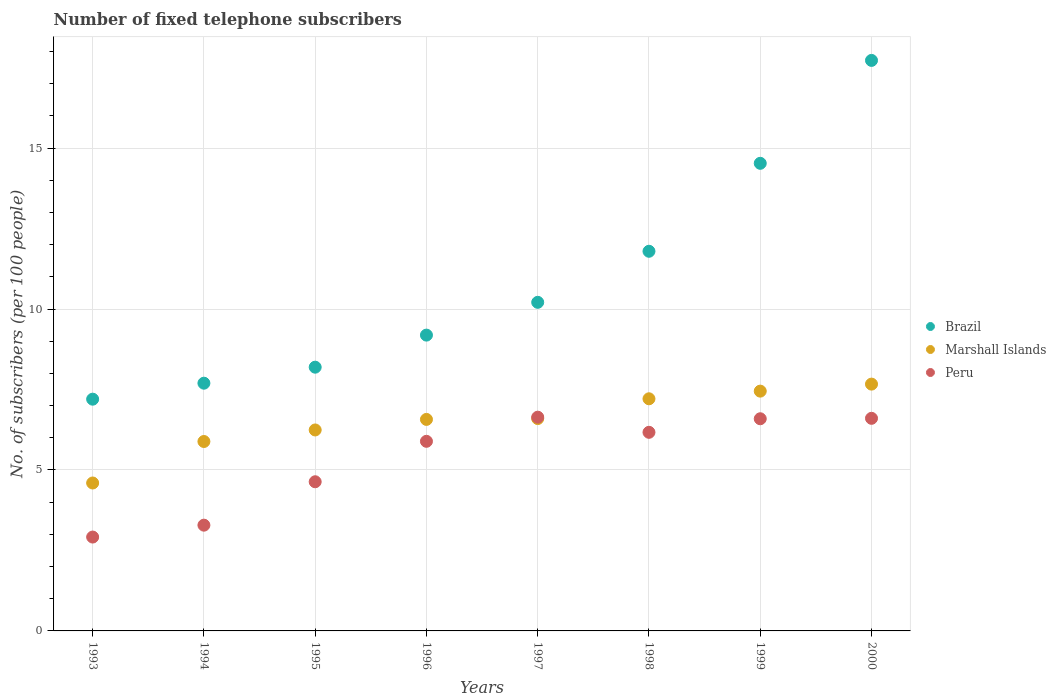How many different coloured dotlines are there?
Your answer should be compact. 3. What is the number of fixed telephone subscribers in Brazil in 2000?
Offer a terse response. 17.72. Across all years, what is the maximum number of fixed telephone subscribers in Peru?
Your response must be concise. 6.64. Across all years, what is the minimum number of fixed telephone subscribers in Marshall Islands?
Offer a terse response. 4.6. In which year was the number of fixed telephone subscribers in Marshall Islands maximum?
Offer a very short reply. 2000. In which year was the number of fixed telephone subscribers in Brazil minimum?
Provide a succinct answer. 1993. What is the total number of fixed telephone subscribers in Peru in the graph?
Offer a very short reply. 42.73. What is the difference between the number of fixed telephone subscribers in Peru in 1993 and that in 1994?
Provide a short and direct response. -0.37. What is the difference between the number of fixed telephone subscribers in Marshall Islands in 1998 and the number of fixed telephone subscribers in Brazil in 1995?
Make the answer very short. -0.98. What is the average number of fixed telephone subscribers in Brazil per year?
Ensure brevity in your answer.  10.82. In the year 1998, what is the difference between the number of fixed telephone subscribers in Brazil and number of fixed telephone subscribers in Marshall Islands?
Your response must be concise. 4.58. In how many years, is the number of fixed telephone subscribers in Marshall Islands greater than 8?
Offer a terse response. 0. What is the ratio of the number of fixed telephone subscribers in Marshall Islands in 1996 to that in 1998?
Your answer should be very brief. 0.91. Is the difference between the number of fixed telephone subscribers in Brazil in 1994 and 2000 greater than the difference between the number of fixed telephone subscribers in Marshall Islands in 1994 and 2000?
Provide a succinct answer. No. What is the difference between the highest and the second highest number of fixed telephone subscribers in Brazil?
Give a very brief answer. 3.2. What is the difference between the highest and the lowest number of fixed telephone subscribers in Peru?
Make the answer very short. 3.72. How many dotlines are there?
Make the answer very short. 3. How many years are there in the graph?
Your answer should be very brief. 8. Are the values on the major ticks of Y-axis written in scientific E-notation?
Your response must be concise. No. Does the graph contain any zero values?
Provide a short and direct response. No. Does the graph contain grids?
Your answer should be compact. Yes. Where does the legend appear in the graph?
Offer a very short reply. Center right. How many legend labels are there?
Your answer should be compact. 3. What is the title of the graph?
Keep it short and to the point. Number of fixed telephone subscribers. What is the label or title of the Y-axis?
Make the answer very short. No. of subscribers (per 100 people). What is the No. of subscribers (per 100 people) in Brazil in 1993?
Make the answer very short. 7.2. What is the No. of subscribers (per 100 people) of Marshall Islands in 1993?
Your answer should be very brief. 4.6. What is the No. of subscribers (per 100 people) of Peru in 1993?
Provide a short and direct response. 2.92. What is the No. of subscribers (per 100 people) in Brazil in 1994?
Make the answer very short. 7.7. What is the No. of subscribers (per 100 people) of Marshall Islands in 1994?
Offer a terse response. 5.88. What is the No. of subscribers (per 100 people) of Peru in 1994?
Provide a short and direct response. 3.29. What is the No. of subscribers (per 100 people) in Brazil in 1995?
Provide a succinct answer. 8.19. What is the No. of subscribers (per 100 people) in Marshall Islands in 1995?
Keep it short and to the point. 6.24. What is the No. of subscribers (per 100 people) in Peru in 1995?
Make the answer very short. 4.63. What is the No. of subscribers (per 100 people) in Brazil in 1996?
Provide a succinct answer. 9.19. What is the No. of subscribers (per 100 people) of Marshall Islands in 1996?
Offer a very short reply. 6.57. What is the No. of subscribers (per 100 people) of Peru in 1996?
Offer a very short reply. 5.89. What is the No. of subscribers (per 100 people) in Brazil in 1997?
Your response must be concise. 10.21. What is the No. of subscribers (per 100 people) of Marshall Islands in 1997?
Make the answer very short. 6.6. What is the No. of subscribers (per 100 people) in Peru in 1997?
Make the answer very short. 6.64. What is the No. of subscribers (per 100 people) in Brazil in 1998?
Provide a short and direct response. 11.79. What is the No. of subscribers (per 100 people) in Marshall Islands in 1998?
Your answer should be very brief. 7.21. What is the No. of subscribers (per 100 people) in Peru in 1998?
Offer a terse response. 6.17. What is the No. of subscribers (per 100 people) of Brazil in 1999?
Provide a succinct answer. 14.53. What is the No. of subscribers (per 100 people) in Marshall Islands in 1999?
Offer a terse response. 7.45. What is the No. of subscribers (per 100 people) of Peru in 1999?
Your answer should be compact. 6.59. What is the No. of subscribers (per 100 people) of Brazil in 2000?
Ensure brevity in your answer.  17.72. What is the No. of subscribers (per 100 people) of Marshall Islands in 2000?
Keep it short and to the point. 7.67. What is the No. of subscribers (per 100 people) of Peru in 2000?
Provide a succinct answer. 6.6. Across all years, what is the maximum No. of subscribers (per 100 people) of Brazil?
Provide a succinct answer. 17.72. Across all years, what is the maximum No. of subscribers (per 100 people) in Marshall Islands?
Provide a succinct answer. 7.67. Across all years, what is the maximum No. of subscribers (per 100 people) of Peru?
Offer a very short reply. 6.64. Across all years, what is the minimum No. of subscribers (per 100 people) in Brazil?
Make the answer very short. 7.2. Across all years, what is the minimum No. of subscribers (per 100 people) of Marshall Islands?
Ensure brevity in your answer.  4.6. Across all years, what is the minimum No. of subscribers (per 100 people) in Peru?
Offer a very short reply. 2.92. What is the total No. of subscribers (per 100 people) of Brazil in the graph?
Keep it short and to the point. 86.52. What is the total No. of subscribers (per 100 people) in Marshall Islands in the graph?
Provide a short and direct response. 52.21. What is the total No. of subscribers (per 100 people) in Peru in the graph?
Give a very brief answer. 42.73. What is the difference between the No. of subscribers (per 100 people) of Brazil in 1993 and that in 1994?
Provide a short and direct response. -0.5. What is the difference between the No. of subscribers (per 100 people) of Marshall Islands in 1993 and that in 1994?
Offer a terse response. -1.29. What is the difference between the No. of subscribers (per 100 people) in Peru in 1993 and that in 1994?
Your response must be concise. -0.37. What is the difference between the No. of subscribers (per 100 people) of Brazil in 1993 and that in 1995?
Make the answer very short. -0.99. What is the difference between the No. of subscribers (per 100 people) of Marshall Islands in 1993 and that in 1995?
Offer a very short reply. -1.65. What is the difference between the No. of subscribers (per 100 people) of Peru in 1993 and that in 1995?
Offer a very short reply. -1.72. What is the difference between the No. of subscribers (per 100 people) in Brazil in 1993 and that in 1996?
Keep it short and to the point. -1.99. What is the difference between the No. of subscribers (per 100 people) of Marshall Islands in 1993 and that in 1996?
Offer a terse response. -1.98. What is the difference between the No. of subscribers (per 100 people) in Peru in 1993 and that in 1996?
Your answer should be compact. -2.97. What is the difference between the No. of subscribers (per 100 people) of Brazil in 1993 and that in 1997?
Your response must be concise. -3.01. What is the difference between the No. of subscribers (per 100 people) in Marshall Islands in 1993 and that in 1997?
Keep it short and to the point. -2. What is the difference between the No. of subscribers (per 100 people) in Peru in 1993 and that in 1997?
Give a very brief answer. -3.72. What is the difference between the No. of subscribers (per 100 people) in Brazil in 1993 and that in 1998?
Provide a succinct answer. -4.59. What is the difference between the No. of subscribers (per 100 people) in Marshall Islands in 1993 and that in 1998?
Ensure brevity in your answer.  -2.62. What is the difference between the No. of subscribers (per 100 people) of Peru in 1993 and that in 1998?
Keep it short and to the point. -3.25. What is the difference between the No. of subscribers (per 100 people) of Brazil in 1993 and that in 1999?
Offer a terse response. -7.33. What is the difference between the No. of subscribers (per 100 people) in Marshall Islands in 1993 and that in 1999?
Make the answer very short. -2.85. What is the difference between the No. of subscribers (per 100 people) of Peru in 1993 and that in 1999?
Your response must be concise. -3.67. What is the difference between the No. of subscribers (per 100 people) in Brazil in 1993 and that in 2000?
Keep it short and to the point. -10.52. What is the difference between the No. of subscribers (per 100 people) in Marshall Islands in 1993 and that in 2000?
Make the answer very short. -3.07. What is the difference between the No. of subscribers (per 100 people) of Peru in 1993 and that in 2000?
Offer a terse response. -3.69. What is the difference between the No. of subscribers (per 100 people) in Brazil in 1994 and that in 1995?
Your answer should be compact. -0.5. What is the difference between the No. of subscribers (per 100 people) in Marshall Islands in 1994 and that in 1995?
Your answer should be compact. -0.36. What is the difference between the No. of subscribers (per 100 people) in Peru in 1994 and that in 1995?
Your answer should be compact. -1.35. What is the difference between the No. of subscribers (per 100 people) of Brazil in 1994 and that in 1996?
Give a very brief answer. -1.49. What is the difference between the No. of subscribers (per 100 people) of Marshall Islands in 1994 and that in 1996?
Your response must be concise. -0.69. What is the difference between the No. of subscribers (per 100 people) in Peru in 1994 and that in 1996?
Offer a very short reply. -2.6. What is the difference between the No. of subscribers (per 100 people) of Brazil in 1994 and that in 1997?
Your answer should be compact. -2.51. What is the difference between the No. of subscribers (per 100 people) of Marshall Islands in 1994 and that in 1997?
Your answer should be very brief. -0.71. What is the difference between the No. of subscribers (per 100 people) in Peru in 1994 and that in 1997?
Keep it short and to the point. -3.35. What is the difference between the No. of subscribers (per 100 people) in Brazil in 1994 and that in 1998?
Give a very brief answer. -4.1. What is the difference between the No. of subscribers (per 100 people) of Marshall Islands in 1994 and that in 1998?
Your answer should be compact. -1.33. What is the difference between the No. of subscribers (per 100 people) of Peru in 1994 and that in 1998?
Your answer should be very brief. -2.88. What is the difference between the No. of subscribers (per 100 people) in Brazil in 1994 and that in 1999?
Keep it short and to the point. -6.83. What is the difference between the No. of subscribers (per 100 people) in Marshall Islands in 1994 and that in 1999?
Your answer should be compact. -1.56. What is the difference between the No. of subscribers (per 100 people) of Peru in 1994 and that in 1999?
Keep it short and to the point. -3.31. What is the difference between the No. of subscribers (per 100 people) in Brazil in 1994 and that in 2000?
Make the answer very short. -10.03. What is the difference between the No. of subscribers (per 100 people) in Marshall Islands in 1994 and that in 2000?
Your answer should be compact. -1.78. What is the difference between the No. of subscribers (per 100 people) in Peru in 1994 and that in 2000?
Give a very brief answer. -3.32. What is the difference between the No. of subscribers (per 100 people) of Brazil in 1995 and that in 1996?
Offer a terse response. -1. What is the difference between the No. of subscribers (per 100 people) in Marshall Islands in 1995 and that in 1996?
Your response must be concise. -0.33. What is the difference between the No. of subscribers (per 100 people) in Peru in 1995 and that in 1996?
Your answer should be compact. -1.26. What is the difference between the No. of subscribers (per 100 people) of Brazil in 1995 and that in 1997?
Give a very brief answer. -2.01. What is the difference between the No. of subscribers (per 100 people) in Marshall Islands in 1995 and that in 1997?
Your response must be concise. -0.35. What is the difference between the No. of subscribers (per 100 people) of Peru in 1995 and that in 1997?
Provide a short and direct response. -2.01. What is the difference between the No. of subscribers (per 100 people) in Brazil in 1995 and that in 1998?
Your answer should be compact. -3.6. What is the difference between the No. of subscribers (per 100 people) in Marshall Islands in 1995 and that in 1998?
Your answer should be very brief. -0.97. What is the difference between the No. of subscribers (per 100 people) of Peru in 1995 and that in 1998?
Keep it short and to the point. -1.54. What is the difference between the No. of subscribers (per 100 people) of Brazil in 1995 and that in 1999?
Keep it short and to the point. -6.33. What is the difference between the No. of subscribers (per 100 people) in Marshall Islands in 1995 and that in 1999?
Offer a very short reply. -1.21. What is the difference between the No. of subscribers (per 100 people) in Peru in 1995 and that in 1999?
Provide a succinct answer. -1.96. What is the difference between the No. of subscribers (per 100 people) of Brazil in 1995 and that in 2000?
Your answer should be very brief. -9.53. What is the difference between the No. of subscribers (per 100 people) in Marshall Islands in 1995 and that in 2000?
Keep it short and to the point. -1.42. What is the difference between the No. of subscribers (per 100 people) of Peru in 1995 and that in 2000?
Ensure brevity in your answer.  -1.97. What is the difference between the No. of subscribers (per 100 people) in Brazil in 1996 and that in 1997?
Your answer should be very brief. -1.02. What is the difference between the No. of subscribers (per 100 people) in Marshall Islands in 1996 and that in 1997?
Make the answer very short. -0.03. What is the difference between the No. of subscribers (per 100 people) in Peru in 1996 and that in 1997?
Your response must be concise. -0.75. What is the difference between the No. of subscribers (per 100 people) of Brazil in 1996 and that in 1998?
Keep it short and to the point. -2.6. What is the difference between the No. of subscribers (per 100 people) in Marshall Islands in 1996 and that in 1998?
Your response must be concise. -0.64. What is the difference between the No. of subscribers (per 100 people) of Peru in 1996 and that in 1998?
Provide a short and direct response. -0.28. What is the difference between the No. of subscribers (per 100 people) of Brazil in 1996 and that in 1999?
Provide a short and direct response. -5.34. What is the difference between the No. of subscribers (per 100 people) of Marshall Islands in 1996 and that in 1999?
Make the answer very short. -0.88. What is the difference between the No. of subscribers (per 100 people) of Peru in 1996 and that in 1999?
Offer a very short reply. -0.7. What is the difference between the No. of subscribers (per 100 people) of Brazil in 1996 and that in 2000?
Your answer should be compact. -8.53. What is the difference between the No. of subscribers (per 100 people) of Marshall Islands in 1996 and that in 2000?
Your answer should be compact. -1.1. What is the difference between the No. of subscribers (per 100 people) in Peru in 1996 and that in 2000?
Make the answer very short. -0.71. What is the difference between the No. of subscribers (per 100 people) in Brazil in 1997 and that in 1998?
Your response must be concise. -1.59. What is the difference between the No. of subscribers (per 100 people) of Marshall Islands in 1997 and that in 1998?
Offer a very short reply. -0.61. What is the difference between the No. of subscribers (per 100 people) in Peru in 1997 and that in 1998?
Your answer should be compact. 0.47. What is the difference between the No. of subscribers (per 100 people) of Brazil in 1997 and that in 1999?
Offer a terse response. -4.32. What is the difference between the No. of subscribers (per 100 people) in Marshall Islands in 1997 and that in 1999?
Ensure brevity in your answer.  -0.85. What is the difference between the No. of subscribers (per 100 people) of Peru in 1997 and that in 1999?
Your answer should be very brief. 0.05. What is the difference between the No. of subscribers (per 100 people) of Brazil in 1997 and that in 2000?
Your response must be concise. -7.51. What is the difference between the No. of subscribers (per 100 people) in Marshall Islands in 1997 and that in 2000?
Provide a succinct answer. -1.07. What is the difference between the No. of subscribers (per 100 people) of Peru in 1997 and that in 2000?
Keep it short and to the point. 0.04. What is the difference between the No. of subscribers (per 100 people) in Brazil in 1998 and that in 1999?
Give a very brief answer. -2.73. What is the difference between the No. of subscribers (per 100 people) of Marshall Islands in 1998 and that in 1999?
Your answer should be compact. -0.24. What is the difference between the No. of subscribers (per 100 people) of Peru in 1998 and that in 1999?
Offer a terse response. -0.42. What is the difference between the No. of subscribers (per 100 people) of Brazil in 1998 and that in 2000?
Offer a terse response. -5.93. What is the difference between the No. of subscribers (per 100 people) in Marshall Islands in 1998 and that in 2000?
Your answer should be compact. -0.46. What is the difference between the No. of subscribers (per 100 people) in Peru in 1998 and that in 2000?
Offer a very short reply. -0.43. What is the difference between the No. of subscribers (per 100 people) of Brazil in 1999 and that in 2000?
Provide a succinct answer. -3.2. What is the difference between the No. of subscribers (per 100 people) of Marshall Islands in 1999 and that in 2000?
Your answer should be compact. -0.22. What is the difference between the No. of subscribers (per 100 people) in Peru in 1999 and that in 2000?
Your answer should be compact. -0.01. What is the difference between the No. of subscribers (per 100 people) in Brazil in 1993 and the No. of subscribers (per 100 people) in Marshall Islands in 1994?
Make the answer very short. 1.31. What is the difference between the No. of subscribers (per 100 people) of Brazil in 1993 and the No. of subscribers (per 100 people) of Peru in 1994?
Ensure brevity in your answer.  3.91. What is the difference between the No. of subscribers (per 100 people) of Marshall Islands in 1993 and the No. of subscribers (per 100 people) of Peru in 1994?
Provide a short and direct response. 1.31. What is the difference between the No. of subscribers (per 100 people) in Brazil in 1993 and the No. of subscribers (per 100 people) in Marshall Islands in 1995?
Provide a short and direct response. 0.96. What is the difference between the No. of subscribers (per 100 people) of Brazil in 1993 and the No. of subscribers (per 100 people) of Peru in 1995?
Provide a succinct answer. 2.57. What is the difference between the No. of subscribers (per 100 people) of Marshall Islands in 1993 and the No. of subscribers (per 100 people) of Peru in 1995?
Ensure brevity in your answer.  -0.04. What is the difference between the No. of subscribers (per 100 people) in Brazil in 1993 and the No. of subscribers (per 100 people) in Marshall Islands in 1996?
Keep it short and to the point. 0.63. What is the difference between the No. of subscribers (per 100 people) of Brazil in 1993 and the No. of subscribers (per 100 people) of Peru in 1996?
Your answer should be compact. 1.31. What is the difference between the No. of subscribers (per 100 people) of Marshall Islands in 1993 and the No. of subscribers (per 100 people) of Peru in 1996?
Give a very brief answer. -1.29. What is the difference between the No. of subscribers (per 100 people) in Brazil in 1993 and the No. of subscribers (per 100 people) in Marshall Islands in 1997?
Your response must be concise. 0.6. What is the difference between the No. of subscribers (per 100 people) in Brazil in 1993 and the No. of subscribers (per 100 people) in Peru in 1997?
Provide a succinct answer. 0.56. What is the difference between the No. of subscribers (per 100 people) of Marshall Islands in 1993 and the No. of subscribers (per 100 people) of Peru in 1997?
Your response must be concise. -2.04. What is the difference between the No. of subscribers (per 100 people) in Brazil in 1993 and the No. of subscribers (per 100 people) in Marshall Islands in 1998?
Your response must be concise. -0.01. What is the difference between the No. of subscribers (per 100 people) in Brazil in 1993 and the No. of subscribers (per 100 people) in Peru in 1998?
Your response must be concise. 1.03. What is the difference between the No. of subscribers (per 100 people) in Marshall Islands in 1993 and the No. of subscribers (per 100 people) in Peru in 1998?
Offer a very short reply. -1.57. What is the difference between the No. of subscribers (per 100 people) of Brazil in 1993 and the No. of subscribers (per 100 people) of Marshall Islands in 1999?
Your answer should be very brief. -0.25. What is the difference between the No. of subscribers (per 100 people) of Brazil in 1993 and the No. of subscribers (per 100 people) of Peru in 1999?
Make the answer very short. 0.61. What is the difference between the No. of subscribers (per 100 people) of Marshall Islands in 1993 and the No. of subscribers (per 100 people) of Peru in 1999?
Make the answer very short. -2. What is the difference between the No. of subscribers (per 100 people) in Brazil in 1993 and the No. of subscribers (per 100 people) in Marshall Islands in 2000?
Provide a short and direct response. -0.47. What is the difference between the No. of subscribers (per 100 people) of Brazil in 1993 and the No. of subscribers (per 100 people) of Peru in 2000?
Provide a short and direct response. 0.59. What is the difference between the No. of subscribers (per 100 people) of Marshall Islands in 1993 and the No. of subscribers (per 100 people) of Peru in 2000?
Offer a terse response. -2.01. What is the difference between the No. of subscribers (per 100 people) of Brazil in 1994 and the No. of subscribers (per 100 people) of Marshall Islands in 1995?
Keep it short and to the point. 1.45. What is the difference between the No. of subscribers (per 100 people) of Brazil in 1994 and the No. of subscribers (per 100 people) of Peru in 1995?
Provide a succinct answer. 3.06. What is the difference between the No. of subscribers (per 100 people) in Marshall Islands in 1994 and the No. of subscribers (per 100 people) in Peru in 1995?
Provide a succinct answer. 1.25. What is the difference between the No. of subscribers (per 100 people) in Brazil in 1994 and the No. of subscribers (per 100 people) in Marshall Islands in 1996?
Your answer should be compact. 1.12. What is the difference between the No. of subscribers (per 100 people) in Brazil in 1994 and the No. of subscribers (per 100 people) in Peru in 1996?
Your answer should be compact. 1.81. What is the difference between the No. of subscribers (per 100 people) in Marshall Islands in 1994 and the No. of subscribers (per 100 people) in Peru in 1996?
Provide a short and direct response. -0.01. What is the difference between the No. of subscribers (per 100 people) in Brazil in 1994 and the No. of subscribers (per 100 people) in Marshall Islands in 1997?
Provide a short and direct response. 1.1. What is the difference between the No. of subscribers (per 100 people) in Brazil in 1994 and the No. of subscribers (per 100 people) in Peru in 1997?
Your response must be concise. 1.06. What is the difference between the No. of subscribers (per 100 people) in Marshall Islands in 1994 and the No. of subscribers (per 100 people) in Peru in 1997?
Give a very brief answer. -0.76. What is the difference between the No. of subscribers (per 100 people) of Brazil in 1994 and the No. of subscribers (per 100 people) of Marshall Islands in 1998?
Ensure brevity in your answer.  0.48. What is the difference between the No. of subscribers (per 100 people) in Brazil in 1994 and the No. of subscribers (per 100 people) in Peru in 1998?
Offer a very short reply. 1.53. What is the difference between the No. of subscribers (per 100 people) of Marshall Islands in 1994 and the No. of subscribers (per 100 people) of Peru in 1998?
Your answer should be very brief. -0.29. What is the difference between the No. of subscribers (per 100 people) of Brazil in 1994 and the No. of subscribers (per 100 people) of Marshall Islands in 1999?
Provide a short and direct response. 0.25. What is the difference between the No. of subscribers (per 100 people) in Brazil in 1994 and the No. of subscribers (per 100 people) in Peru in 1999?
Your answer should be compact. 1.1. What is the difference between the No. of subscribers (per 100 people) of Marshall Islands in 1994 and the No. of subscribers (per 100 people) of Peru in 1999?
Offer a very short reply. -0.71. What is the difference between the No. of subscribers (per 100 people) of Brazil in 1994 and the No. of subscribers (per 100 people) of Marshall Islands in 2000?
Your response must be concise. 0.03. What is the difference between the No. of subscribers (per 100 people) of Brazil in 1994 and the No. of subscribers (per 100 people) of Peru in 2000?
Offer a terse response. 1.09. What is the difference between the No. of subscribers (per 100 people) in Marshall Islands in 1994 and the No. of subscribers (per 100 people) in Peru in 2000?
Offer a terse response. -0.72. What is the difference between the No. of subscribers (per 100 people) of Brazil in 1995 and the No. of subscribers (per 100 people) of Marshall Islands in 1996?
Keep it short and to the point. 1.62. What is the difference between the No. of subscribers (per 100 people) of Brazil in 1995 and the No. of subscribers (per 100 people) of Peru in 1996?
Your answer should be compact. 2.3. What is the difference between the No. of subscribers (per 100 people) of Marshall Islands in 1995 and the No. of subscribers (per 100 people) of Peru in 1996?
Offer a very short reply. 0.35. What is the difference between the No. of subscribers (per 100 people) in Brazil in 1995 and the No. of subscribers (per 100 people) in Marshall Islands in 1997?
Your answer should be compact. 1.6. What is the difference between the No. of subscribers (per 100 people) of Brazil in 1995 and the No. of subscribers (per 100 people) of Peru in 1997?
Provide a short and direct response. 1.55. What is the difference between the No. of subscribers (per 100 people) of Marshall Islands in 1995 and the No. of subscribers (per 100 people) of Peru in 1997?
Make the answer very short. -0.4. What is the difference between the No. of subscribers (per 100 people) in Brazil in 1995 and the No. of subscribers (per 100 people) in Marshall Islands in 1998?
Offer a very short reply. 0.98. What is the difference between the No. of subscribers (per 100 people) in Brazil in 1995 and the No. of subscribers (per 100 people) in Peru in 1998?
Your response must be concise. 2.02. What is the difference between the No. of subscribers (per 100 people) in Marshall Islands in 1995 and the No. of subscribers (per 100 people) in Peru in 1998?
Offer a terse response. 0.07. What is the difference between the No. of subscribers (per 100 people) of Brazil in 1995 and the No. of subscribers (per 100 people) of Marshall Islands in 1999?
Your answer should be very brief. 0.74. What is the difference between the No. of subscribers (per 100 people) in Brazil in 1995 and the No. of subscribers (per 100 people) in Peru in 1999?
Your response must be concise. 1.6. What is the difference between the No. of subscribers (per 100 people) in Marshall Islands in 1995 and the No. of subscribers (per 100 people) in Peru in 1999?
Offer a very short reply. -0.35. What is the difference between the No. of subscribers (per 100 people) of Brazil in 1995 and the No. of subscribers (per 100 people) of Marshall Islands in 2000?
Your answer should be very brief. 0.53. What is the difference between the No. of subscribers (per 100 people) in Brazil in 1995 and the No. of subscribers (per 100 people) in Peru in 2000?
Your answer should be compact. 1.59. What is the difference between the No. of subscribers (per 100 people) of Marshall Islands in 1995 and the No. of subscribers (per 100 people) of Peru in 2000?
Offer a terse response. -0.36. What is the difference between the No. of subscribers (per 100 people) in Brazil in 1996 and the No. of subscribers (per 100 people) in Marshall Islands in 1997?
Provide a succinct answer. 2.59. What is the difference between the No. of subscribers (per 100 people) of Brazil in 1996 and the No. of subscribers (per 100 people) of Peru in 1997?
Your answer should be compact. 2.55. What is the difference between the No. of subscribers (per 100 people) of Marshall Islands in 1996 and the No. of subscribers (per 100 people) of Peru in 1997?
Make the answer very short. -0.07. What is the difference between the No. of subscribers (per 100 people) in Brazil in 1996 and the No. of subscribers (per 100 people) in Marshall Islands in 1998?
Ensure brevity in your answer.  1.98. What is the difference between the No. of subscribers (per 100 people) in Brazil in 1996 and the No. of subscribers (per 100 people) in Peru in 1998?
Ensure brevity in your answer.  3.02. What is the difference between the No. of subscribers (per 100 people) in Marshall Islands in 1996 and the No. of subscribers (per 100 people) in Peru in 1998?
Offer a very short reply. 0.4. What is the difference between the No. of subscribers (per 100 people) in Brazil in 1996 and the No. of subscribers (per 100 people) in Marshall Islands in 1999?
Your answer should be compact. 1.74. What is the difference between the No. of subscribers (per 100 people) in Brazil in 1996 and the No. of subscribers (per 100 people) in Peru in 1999?
Offer a terse response. 2.6. What is the difference between the No. of subscribers (per 100 people) of Marshall Islands in 1996 and the No. of subscribers (per 100 people) of Peru in 1999?
Your response must be concise. -0.02. What is the difference between the No. of subscribers (per 100 people) in Brazil in 1996 and the No. of subscribers (per 100 people) in Marshall Islands in 2000?
Provide a short and direct response. 1.52. What is the difference between the No. of subscribers (per 100 people) in Brazil in 1996 and the No. of subscribers (per 100 people) in Peru in 2000?
Provide a succinct answer. 2.58. What is the difference between the No. of subscribers (per 100 people) of Marshall Islands in 1996 and the No. of subscribers (per 100 people) of Peru in 2000?
Make the answer very short. -0.03. What is the difference between the No. of subscribers (per 100 people) in Brazil in 1997 and the No. of subscribers (per 100 people) in Marshall Islands in 1998?
Keep it short and to the point. 3. What is the difference between the No. of subscribers (per 100 people) of Brazil in 1997 and the No. of subscribers (per 100 people) of Peru in 1998?
Give a very brief answer. 4.04. What is the difference between the No. of subscribers (per 100 people) in Marshall Islands in 1997 and the No. of subscribers (per 100 people) in Peru in 1998?
Ensure brevity in your answer.  0.43. What is the difference between the No. of subscribers (per 100 people) in Brazil in 1997 and the No. of subscribers (per 100 people) in Marshall Islands in 1999?
Your response must be concise. 2.76. What is the difference between the No. of subscribers (per 100 people) of Brazil in 1997 and the No. of subscribers (per 100 people) of Peru in 1999?
Give a very brief answer. 3.62. What is the difference between the No. of subscribers (per 100 people) in Marshall Islands in 1997 and the No. of subscribers (per 100 people) in Peru in 1999?
Offer a very short reply. 0.01. What is the difference between the No. of subscribers (per 100 people) of Brazil in 1997 and the No. of subscribers (per 100 people) of Marshall Islands in 2000?
Offer a terse response. 2.54. What is the difference between the No. of subscribers (per 100 people) in Brazil in 1997 and the No. of subscribers (per 100 people) in Peru in 2000?
Give a very brief answer. 3.6. What is the difference between the No. of subscribers (per 100 people) of Marshall Islands in 1997 and the No. of subscribers (per 100 people) of Peru in 2000?
Your response must be concise. -0.01. What is the difference between the No. of subscribers (per 100 people) of Brazil in 1998 and the No. of subscribers (per 100 people) of Marshall Islands in 1999?
Your answer should be compact. 4.34. What is the difference between the No. of subscribers (per 100 people) in Brazil in 1998 and the No. of subscribers (per 100 people) in Peru in 1999?
Keep it short and to the point. 5.2. What is the difference between the No. of subscribers (per 100 people) of Marshall Islands in 1998 and the No. of subscribers (per 100 people) of Peru in 1999?
Make the answer very short. 0.62. What is the difference between the No. of subscribers (per 100 people) of Brazil in 1998 and the No. of subscribers (per 100 people) of Marshall Islands in 2000?
Make the answer very short. 4.13. What is the difference between the No. of subscribers (per 100 people) of Brazil in 1998 and the No. of subscribers (per 100 people) of Peru in 2000?
Offer a very short reply. 5.19. What is the difference between the No. of subscribers (per 100 people) of Marshall Islands in 1998 and the No. of subscribers (per 100 people) of Peru in 2000?
Keep it short and to the point. 0.61. What is the difference between the No. of subscribers (per 100 people) of Brazil in 1999 and the No. of subscribers (per 100 people) of Marshall Islands in 2000?
Offer a very short reply. 6.86. What is the difference between the No. of subscribers (per 100 people) of Brazil in 1999 and the No. of subscribers (per 100 people) of Peru in 2000?
Offer a very short reply. 7.92. What is the difference between the No. of subscribers (per 100 people) of Marshall Islands in 1999 and the No. of subscribers (per 100 people) of Peru in 2000?
Offer a very short reply. 0.84. What is the average No. of subscribers (per 100 people) in Brazil per year?
Your answer should be compact. 10.82. What is the average No. of subscribers (per 100 people) in Marshall Islands per year?
Your response must be concise. 6.53. What is the average No. of subscribers (per 100 people) of Peru per year?
Offer a terse response. 5.34. In the year 1993, what is the difference between the No. of subscribers (per 100 people) in Brazil and No. of subscribers (per 100 people) in Marshall Islands?
Your answer should be compact. 2.6. In the year 1993, what is the difference between the No. of subscribers (per 100 people) in Brazil and No. of subscribers (per 100 people) in Peru?
Give a very brief answer. 4.28. In the year 1993, what is the difference between the No. of subscribers (per 100 people) of Marshall Islands and No. of subscribers (per 100 people) of Peru?
Your answer should be very brief. 1.68. In the year 1994, what is the difference between the No. of subscribers (per 100 people) in Brazil and No. of subscribers (per 100 people) in Marshall Islands?
Give a very brief answer. 1.81. In the year 1994, what is the difference between the No. of subscribers (per 100 people) in Brazil and No. of subscribers (per 100 people) in Peru?
Offer a terse response. 4.41. In the year 1994, what is the difference between the No. of subscribers (per 100 people) in Marshall Islands and No. of subscribers (per 100 people) in Peru?
Give a very brief answer. 2.6. In the year 1995, what is the difference between the No. of subscribers (per 100 people) of Brazil and No. of subscribers (per 100 people) of Marshall Islands?
Your answer should be very brief. 1.95. In the year 1995, what is the difference between the No. of subscribers (per 100 people) in Brazil and No. of subscribers (per 100 people) in Peru?
Offer a very short reply. 3.56. In the year 1995, what is the difference between the No. of subscribers (per 100 people) of Marshall Islands and No. of subscribers (per 100 people) of Peru?
Give a very brief answer. 1.61. In the year 1996, what is the difference between the No. of subscribers (per 100 people) of Brazil and No. of subscribers (per 100 people) of Marshall Islands?
Offer a terse response. 2.62. In the year 1996, what is the difference between the No. of subscribers (per 100 people) of Brazil and No. of subscribers (per 100 people) of Peru?
Your answer should be very brief. 3.3. In the year 1996, what is the difference between the No. of subscribers (per 100 people) in Marshall Islands and No. of subscribers (per 100 people) in Peru?
Your answer should be compact. 0.68. In the year 1997, what is the difference between the No. of subscribers (per 100 people) of Brazil and No. of subscribers (per 100 people) of Marshall Islands?
Give a very brief answer. 3.61. In the year 1997, what is the difference between the No. of subscribers (per 100 people) in Brazil and No. of subscribers (per 100 people) in Peru?
Keep it short and to the point. 3.57. In the year 1997, what is the difference between the No. of subscribers (per 100 people) of Marshall Islands and No. of subscribers (per 100 people) of Peru?
Offer a very short reply. -0.04. In the year 1998, what is the difference between the No. of subscribers (per 100 people) in Brazil and No. of subscribers (per 100 people) in Marshall Islands?
Offer a terse response. 4.58. In the year 1998, what is the difference between the No. of subscribers (per 100 people) of Brazil and No. of subscribers (per 100 people) of Peru?
Your response must be concise. 5.62. In the year 1998, what is the difference between the No. of subscribers (per 100 people) of Marshall Islands and No. of subscribers (per 100 people) of Peru?
Ensure brevity in your answer.  1.04. In the year 1999, what is the difference between the No. of subscribers (per 100 people) of Brazil and No. of subscribers (per 100 people) of Marshall Islands?
Your answer should be very brief. 7.08. In the year 1999, what is the difference between the No. of subscribers (per 100 people) in Brazil and No. of subscribers (per 100 people) in Peru?
Offer a terse response. 7.93. In the year 1999, what is the difference between the No. of subscribers (per 100 people) in Marshall Islands and No. of subscribers (per 100 people) in Peru?
Your answer should be very brief. 0.86. In the year 2000, what is the difference between the No. of subscribers (per 100 people) in Brazil and No. of subscribers (per 100 people) in Marshall Islands?
Give a very brief answer. 10.06. In the year 2000, what is the difference between the No. of subscribers (per 100 people) of Brazil and No. of subscribers (per 100 people) of Peru?
Provide a short and direct response. 11.12. In the year 2000, what is the difference between the No. of subscribers (per 100 people) of Marshall Islands and No. of subscribers (per 100 people) of Peru?
Ensure brevity in your answer.  1.06. What is the ratio of the No. of subscribers (per 100 people) in Brazil in 1993 to that in 1994?
Provide a succinct answer. 0.94. What is the ratio of the No. of subscribers (per 100 people) of Marshall Islands in 1993 to that in 1994?
Your answer should be very brief. 0.78. What is the ratio of the No. of subscribers (per 100 people) in Peru in 1993 to that in 1994?
Ensure brevity in your answer.  0.89. What is the ratio of the No. of subscribers (per 100 people) in Brazil in 1993 to that in 1995?
Provide a short and direct response. 0.88. What is the ratio of the No. of subscribers (per 100 people) in Marshall Islands in 1993 to that in 1995?
Your response must be concise. 0.74. What is the ratio of the No. of subscribers (per 100 people) in Peru in 1993 to that in 1995?
Give a very brief answer. 0.63. What is the ratio of the No. of subscribers (per 100 people) of Brazil in 1993 to that in 1996?
Make the answer very short. 0.78. What is the ratio of the No. of subscribers (per 100 people) in Marshall Islands in 1993 to that in 1996?
Provide a succinct answer. 0.7. What is the ratio of the No. of subscribers (per 100 people) in Peru in 1993 to that in 1996?
Keep it short and to the point. 0.49. What is the ratio of the No. of subscribers (per 100 people) of Brazil in 1993 to that in 1997?
Give a very brief answer. 0.71. What is the ratio of the No. of subscribers (per 100 people) in Marshall Islands in 1993 to that in 1997?
Keep it short and to the point. 0.7. What is the ratio of the No. of subscribers (per 100 people) of Peru in 1993 to that in 1997?
Give a very brief answer. 0.44. What is the ratio of the No. of subscribers (per 100 people) in Brazil in 1993 to that in 1998?
Make the answer very short. 0.61. What is the ratio of the No. of subscribers (per 100 people) in Marshall Islands in 1993 to that in 1998?
Keep it short and to the point. 0.64. What is the ratio of the No. of subscribers (per 100 people) in Peru in 1993 to that in 1998?
Your answer should be very brief. 0.47. What is the ratio of the No. of subscribers (per 100 people) of Brazil in 1993 to that in 1999?
Keep it short and to the point. 0.5. What is the ratio of the No. of subscribers (per 100 people) of Marshall Islands in 1993 to that in 1999?
Your answer should be compact. 0.62. What is the ratio of the No. of subscribers (per 100 people) in Peru in 1993 to that in 1999?
Keep it short and to the point. 0.44. What is the ratio of the No. of subscribers (per 100 people) of Brazil in 1993 to that in 2000?
Keep it short and to the point. 0.41. What is the ratio of the No. of subscribers (per 100 people) in Marshall Islands in 1993 to that in 2000?
Ensure brevity in your answer.  0.6. What is the ratio of the No. of subscribers (per 100 people) in Peru in 1993 to that in 2000?
Keep it short and to the point. 0.44. What is the ratio of the No. of subscribers (per 100 people) of Brazil in 1994 to that in 1995?
Your answer should be compact. 0.94. What is the ratio of the No. of subscribers (per 100 people) of Marshall Islands in 1994 to that in 1995?
Offer a very short reply. 0.94. What is the ratio of the No. of subscribers (per 100 people) of Peru in 1994 to that in 1995?
Offer a very short reply. 0.71. What is the ratio of the No. of subscribers (per 100 people) of Brazil in 1994 to that in 1996?
Provide a succinct answer. 0.84. What is the ratio of the No. of subscribers (per 100 people) of Marshall Islands in 1994 to that in 1996?
Your answer should be compact. 0.9. What is the ratio of the No. of subscribers (per 100 people) in Peru in 1994 to that in 1996?
Offer a very short reply. 0.56. What is the ratio of the No. of subscribers (per 100 people) in Brazil in 1994 to that in 1997?
Offer a very short reply. 0.75. What is the ratio of the No. of subscribers (per 100 people) of Marshall Islands in 1994 to that in 1997?
Offer a terse response. 0.89. What is the ratio of the No. of subscribers (per 100 people) of Peru in 1994 to that in 1997?
Offer a terse response. 0.49. What is the ratio of the No. of subscribers (per 100 people) of Brazil in 1994 to that in 1998?
Provide a succinct answer. 0.65. What is the ratio of the No. of subscribers (per 100 people) of Marshall Islands in 1994 to that in 1998?
Offer a terse response. 0.82. What is the ratio of the No. of subscribers (per 100 people) in Peru in 1994 to that in 1998?
Your response must be concise. 0.53. What is the ratio of the No. of subscribers (per 100 people) in Brazil in 1994 to that in 1999?
Keep it short and to the point. 0.53. What is the ratio of the No. of subscribers (per 100 people) in Marshall Islands in 1994 to that in 1999?
Offer a terse response. 0.79. What is the ratio of the No. of subscribers (per 100 people) of Peru in 1994 to that in 1999?
Offer a very short reply. 0.5. What is the ratio of the No. of subscribers (per 100 people) in Brazil in 1994 to that in 2000?
Make the answer very short. 0.43. What is the ratio of the No. of subscribers (per 100 people) in Marshall Islands in 1994 to that in 2000?
Keep it short and to the point. 0.77. What is the ratio of the No. of subscribers (per 100 people) in Peru in 1994 to that in 2000?
Provide a short and direct response. 0.5. What is the ratio of the No. of subscribers (per 100 people) in Brazil in 1995 to that in 1996?
Your answer should be very brief. 0.89. What is the ratio of the No. of subscribers (per 100 people) of Marshall Islands in 1995 to that in 1996?
Give a very brief answer. 0.95. What is the ratio of the No. of subscribers (per 100 people) of Peru in 1995 to that in 1996?
Your answer should be compact. 0.79. What is the ratio of the No. of subscribers (per 100 people) in Brazil in 1995 to that in 1997?
Provide a short and direct response. 0.8. What is the ratio of the No. of subscribers (per 100 people) of Marshall Islands in 1995 to that in 1997?
Your answer should be very brief. 0.95. What is the ratio of the No. of subscribers (per 100 people) in Peru in 1995 to that in 1997?
Provide a short and direct response. 0.7. What is the ratio of the No. of subscribers (per 100 people) of Brazil in 1995 to that in 1998?
Give a very brief answer. 0.69. What is the ratio of the No. of subscribers (per 100 people) in Marshall Islands in 1995 to that in 1998?
Your answer should be very brief. 0.87. What is the ratio of the No. of subscribers (per 100 people) of Peru in 1995 to that in 1998?
Your answer should be compact. 0.75. What is the ratio of the No. of subscribers (per 100 people) in Brazil in 1995 to that in 1999?
Provide a short and direct response. 0.56. What is the ratio of the No. of subscribers (per 100 people) in Marshall Islands in 1995 to that in 1999?
Provide a short and direct response. 0.84. What is the ratio of the No. of subscribers (per 100 people) in Peru in 1995 to that in 1999?
Your response must be concise. 0.7. What is the ratio of the No. of subscribers (per 100 people) of Brazil in 1995 to that in 2000?
Offer a terse response. 0.46. What is the ratio of the No. of subscribers (per 100 people) of Marshall Islands in 1995 to that in 2000?
Your answer should be compact. 0.81. What is the ratio of the No. of subscribers (per 100 people) of Peru in 1995 to that in 2000?
Provide a succinct answer. 0.7. What is the ratio of the No. of subscribers (per 100 people) of Brazil in 1996 to that in 1997?
Your answer should be very brief. 0.9. What is the ratio of the No. of subscribers (per 100 people) of Peru in 1996 to that in 1997?
Keep it short and to the point. 0.89. What is the ratio of the No. of subscribers (per 100 people) in Brazil in 1996 to that in 1998?
Make the answer very short. 0.78. What is the ratio of the No. of subscribers (per 100 people) in Marshall Islands in 1996 to that in 1998?
Offer a terse response. 0.91. What is the ratio of the No. of subscribers (per 100 people) in Peru in 1996 to that in 1998?
Your answer should be very brief. 0.95. What is the ratio of the No. of subscribers (per 100 people) of Brazil in 1996 to that in 1999?
Ensure brevity in your answer.  0.63. What is the ratio of the No. of subscribers (per 100 people) in Marshall Islands in 1996 to that in 1999?
Your answer should be very brief. 0.88. What is the ratio of the No. of subscribers (per 100 people) in Peru in 1996 to that in 1999?
Your response must be concise. 0.89. What is the ratio of the No. of subscribers (per 100 people) in Brazil in 1996 to that in 2000?
Give a very brief answer. 0.52. What is the ratio of the No. of subscribers (per 100 people) in Marshall Islands in 1996 to that in 2000?
Ensure brevity in your answer.  0.86. What is the ratio of the No. of subscribers (per 100 people) of Peru in 1996 to that in 2000?
Offer a terse response. 0.89. What is the ratio of the No. of subscribers (per 100 people) in Brazil in 1997 to that in 1998?
Provide a succinct answer. 0.87. What is the ratio of the No. of subscribers (per 100 people) in Marshall Islands in 1997 to that in 1998?
Keep it short and to the point. 0.91. What is the ratio of the No. of subscribers (per 100 people) in Peru in 1997 to that in 1998?
Offer a terse response. 1.08. What is the ratio of the No. of subscribers (per 100 people) of Brazil in 1997 to that in 1999?
Make the answer very short. 0.7. What is the ratio of the No. of subscribers (per 100 people) of Marshall Islands in 1997 to that in 1999?
Your response must be concise. 0.89. What is the ratio of the No. of subscribers (per 100 people) of Peru in 1997 to that in 1999?
Give a very brief answer. 1.01. What is the ratio of the No. of subscribers (per 100 people) of Brazil in 1997 to that in 2000?
Your answer should be compact. 0.58. What is the ratio of the No. of subscribers (per 100 people) in Marshall Islands in 1997 to that in 2000?
Make the answer very short. 0.86. What is the ratio of the No. of subscribers (per 100 people) of Peru in 1997 to that in 2000?
Your response must be concise. 1.01. What is the ratio of the No. of subscribers (per 100 people) in Brazil in 1998 to that in 1999?
Your response must be concise. 0.81. What is the ratio of the No. of subscribers (per 100 people) of Marshall Islands in 1998 to that in 1999?
Keep it short and to the point. 0.97. What is the ratio of the No. of subscribers (per 100 people) in Peru in 1998 to that in 1999?
Your answer should be compact. 0.94. What is the ratio of the No. of subscribers (per 100 people) in Brazil in 1998 to that in 2000?
Ensure brevity in your answer.  0.67. What is the ratio of the No. of subscribers (per 100 people) of Marshall Islands in 1998 to that in 2000?
Give a very brief answer. 0.94. What is the ratio of the No. of subscribers (per 100 people) of Peru in 1998 to that in 2000?
Your answer should be very brief. 0.93. What is the ratio of the No. of subscribers (per 100 people) of Brazil in 1999 to that in 2000?
Offer a terse response. 0.82. What is the ratio of the No. of subscribers (per 100 people) in Marshall Islands in 1999 to that in 2000?
Give a very brief answer. 0.97. What is the ratio of the No. of subscribers (per 100 people) of Peru in 1999 to that in 2000?
Provide a short and direct response. 1. What is the difference between the highest and the second highest No. of subscribers (per 100 people) in Brazil?
Keep it short and to the point. 3.2. What is the difference between the highest and the second highest No. of subscribers (per 100 people) in Marshall Islands?
Your answer should be compact. 0.22. What is the difference between the highest and the second highest No. of subscribers (per 100 people) of Peru?
Provide a succinct answer. 0.04. What is the difference between the highest and the lowest No. of subscribers (per 100 people) in Brazil?
Make the answer very short. 10.52. What is the difference between the highest and the lowest No. of subscribers (per 100 people) of Marshall Islands?
Offer a very short reply. 3.07. What is the difference between the highest and the lowest No. of subscribers (per 100 people) of Peru?
Your response must be concise. 3.72. 